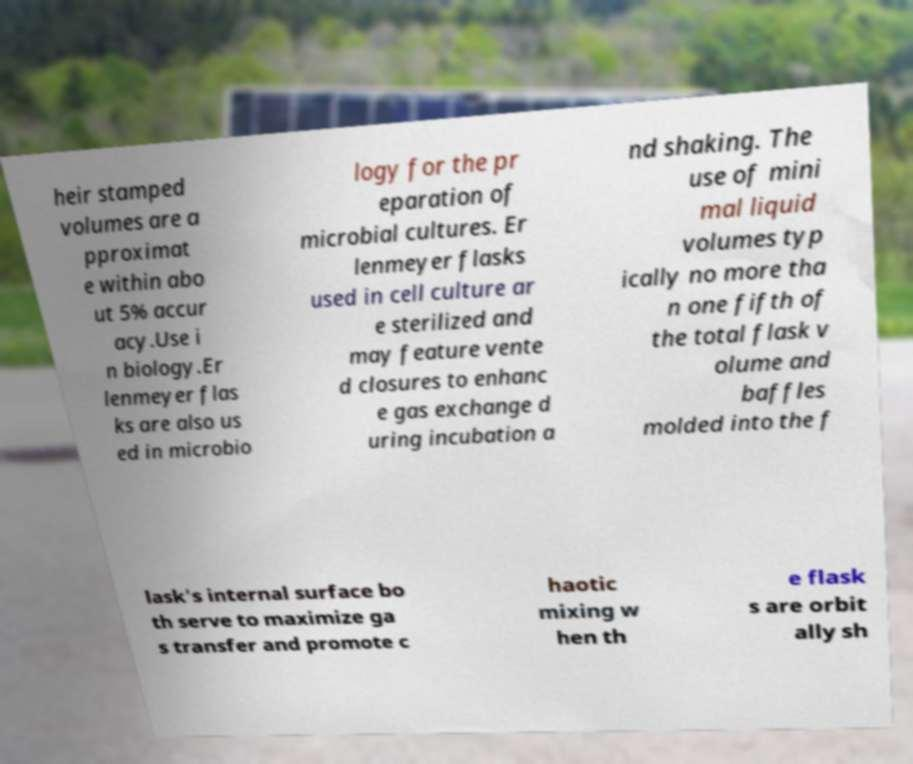Could you assist in decoding the text presented in this image and type it out clearly? heir stamped volumes are a pproximat e within abo ut 5% accur acy.Use i n biology.Er lenmeyer flas ks are also us ed in microbio logy for the pr eparation of microbial cultures. Er lenmeyer flasks used in cell culture ar e sterilized and may feature vente d closures to enhanc e gas exchange d uring incubation a nd shaking. The use of mini mal liquid volumes typ ically no more tha n one fifth of the total flask v olume and baffles molded into the f lask's internal surface bo th serve to maximize ga s transfer and promote c haotic mixing w hen th e flask s are orbit ally sh 